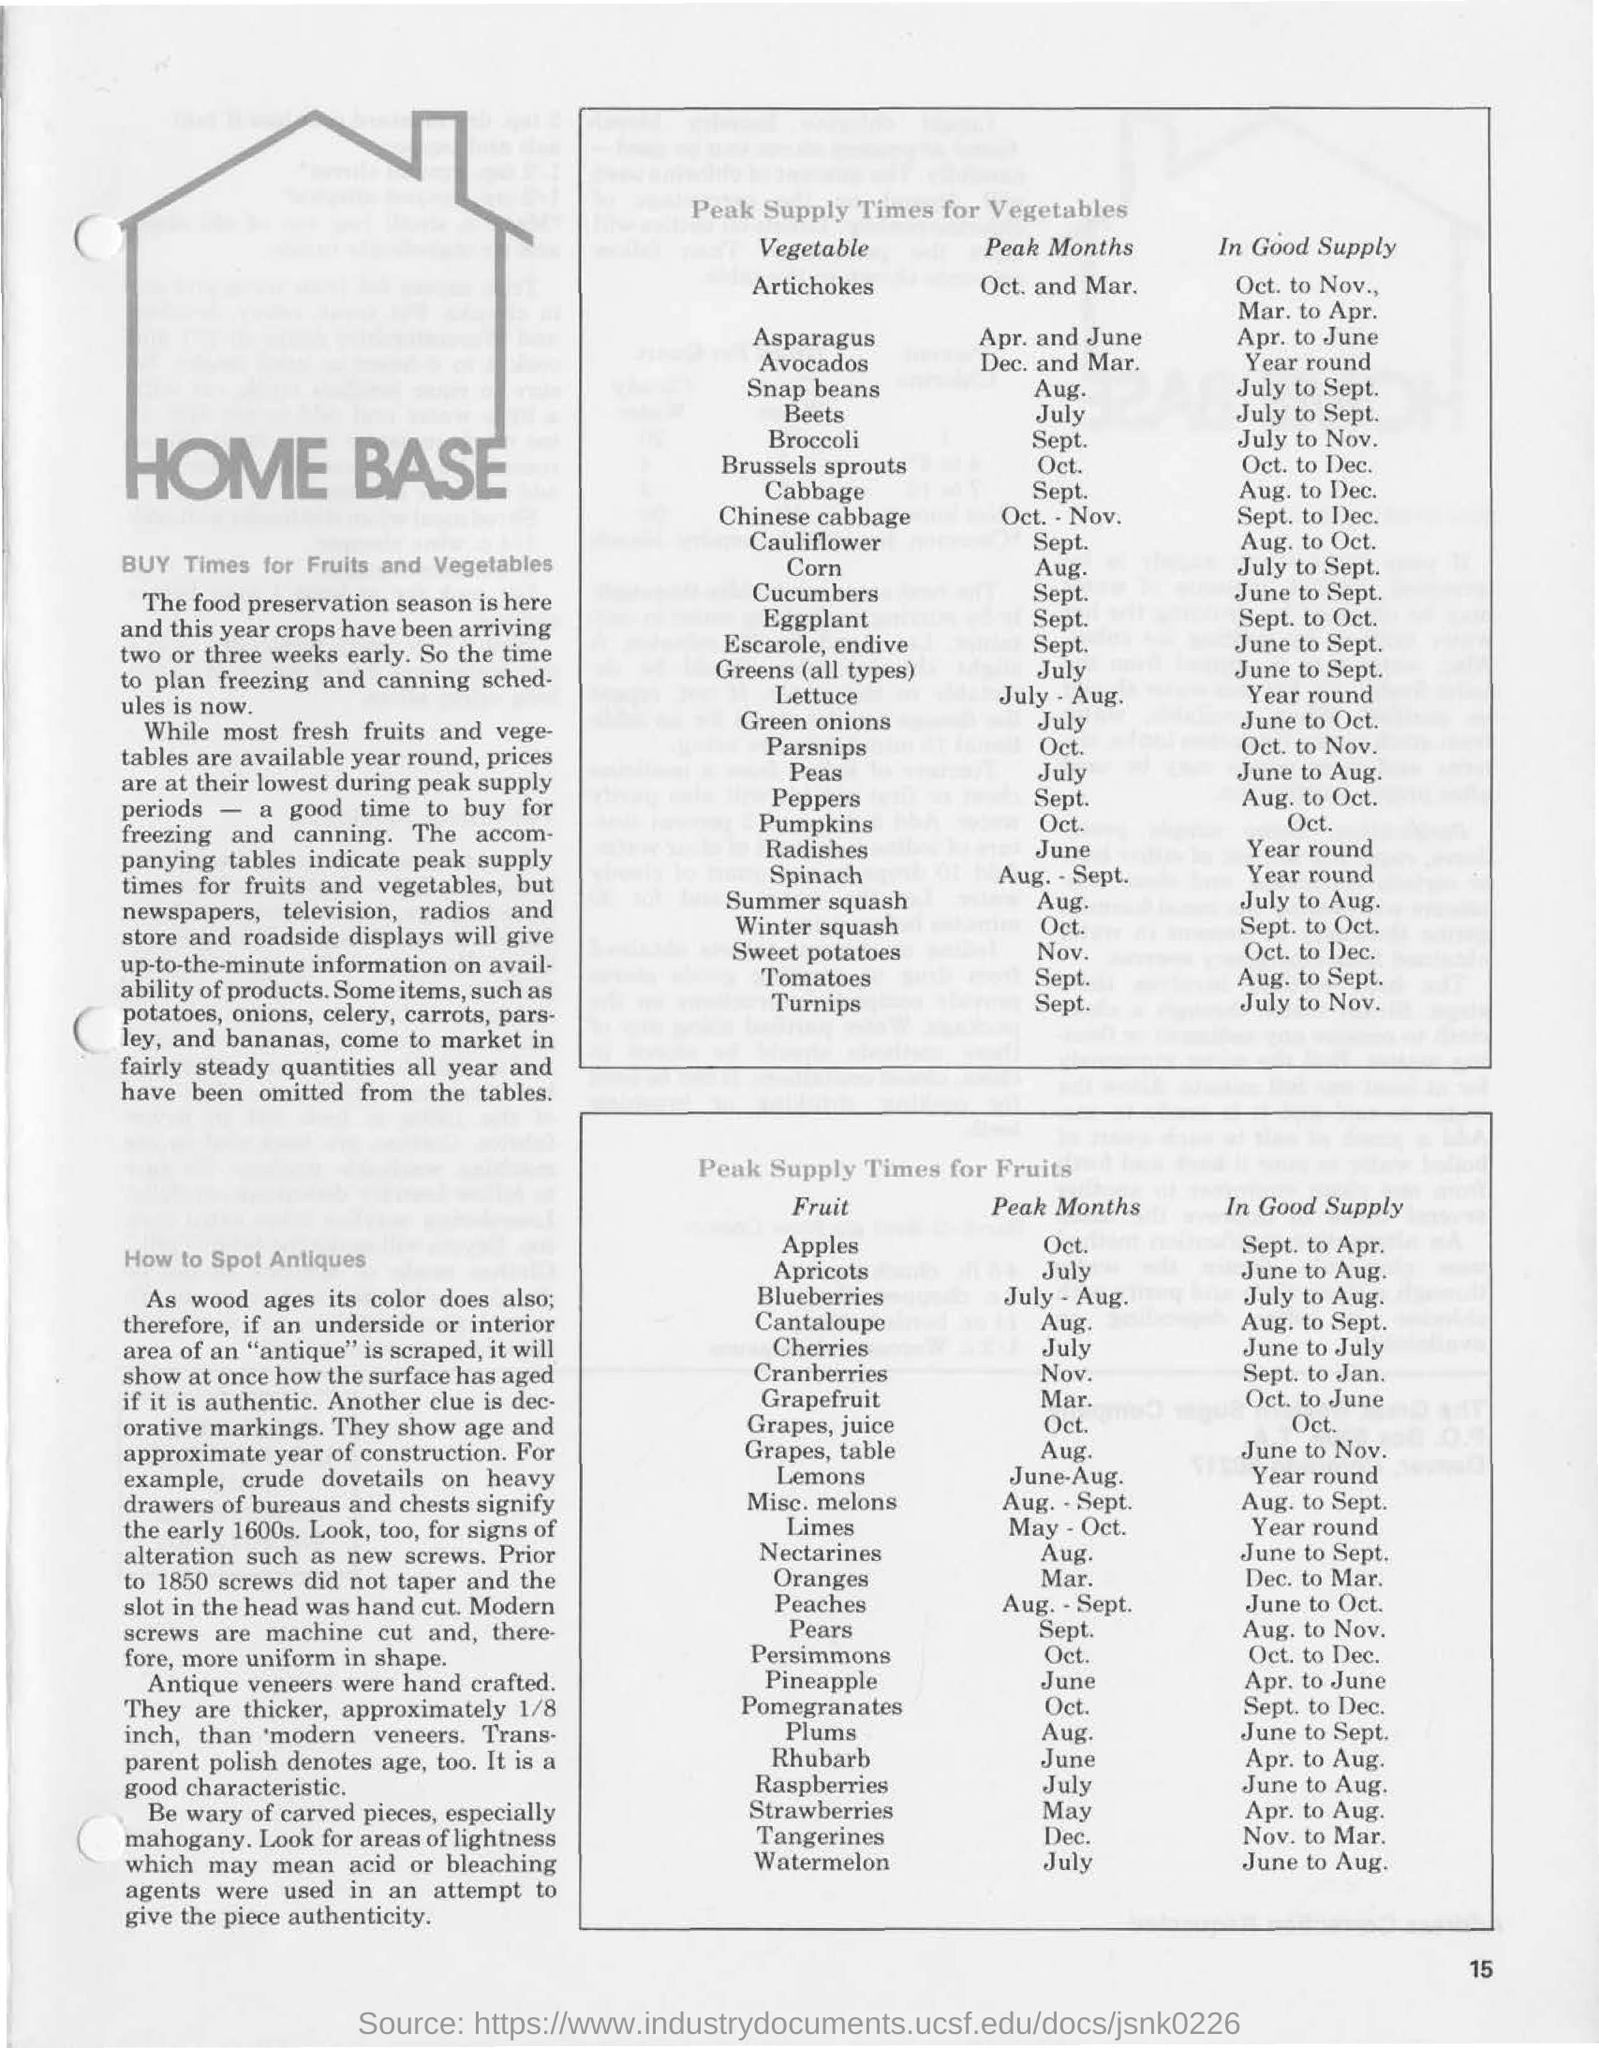When is the peak supply time for artichokes?
Provide a succinct answer. Oct. and mar. When is the peak supply time for beets?
Your answer should be compact. JULY. When is the peak supply time for apples?
Your answer should be very brief. OCT. When is cabbage in good supply?
Offer a terse response. Aug. to dec. When are plums in good supply?
Ensure brevity in your answer.  JUNE TO SEPT. 